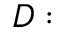<formula> <loc_0><loc_0><loc_500><loc_500>D \colon</formula> 